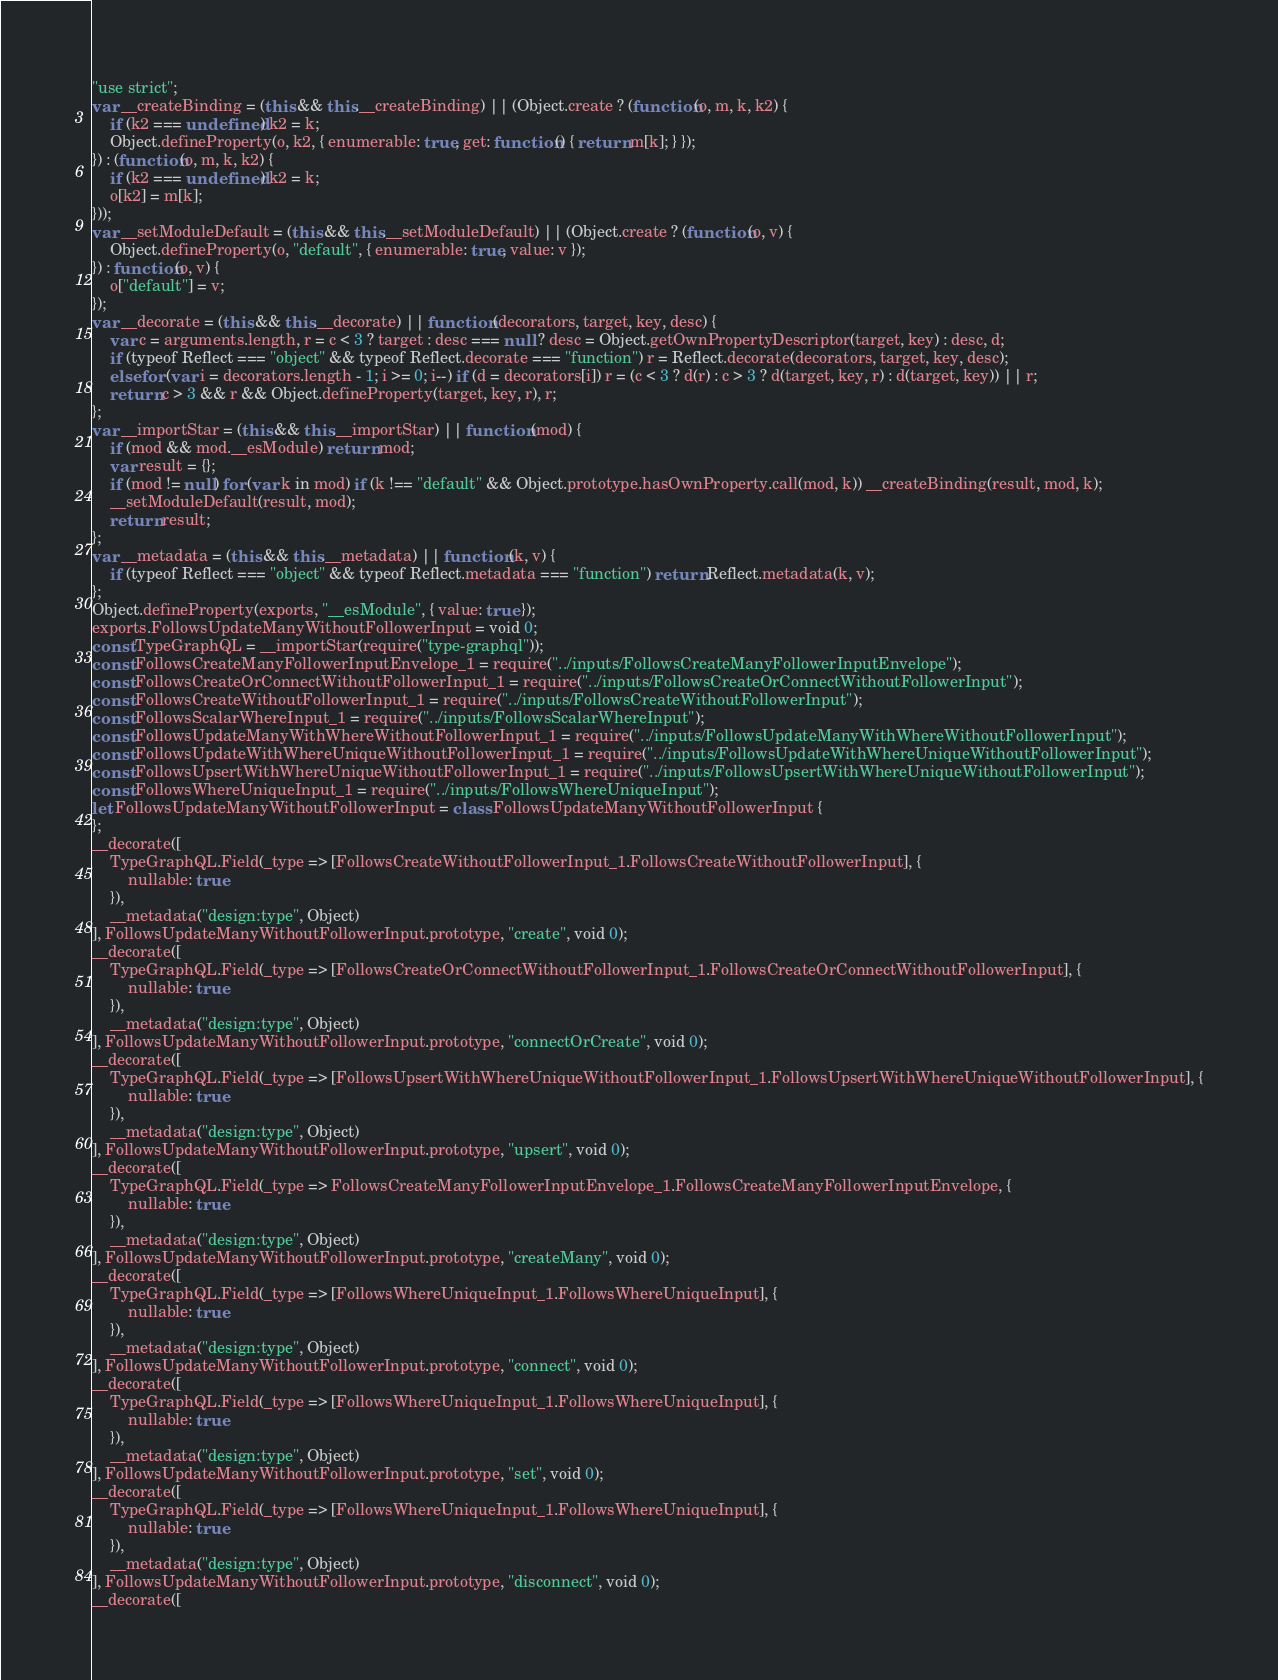Convert code to text. <code><loc_0><loc_0><loc_500><loc_500><_JavaScript_>"use strict";
var __createBinding = (this && this.__createBinding) || (Object.create ? (function(o, m, k, k2) {
    if (k2 === undefined) k2 = k;
    Object.defineProperty(o, k2, { enumerable: true, get: function() { return m[k]; } });
}) : (function(o, m, k, k2) {
    if (k2 === undefined) k2 = k;
    o[k2] = m[k];
}));
var __setModuleDefault = (this && this.__setModuleDefault) || (Object.create ? (function(o, v) {
    Object.defineProperty(o, "default", { enumerable: true, value: v });
}) : function(o, v) {
    o["default"] = v;
});
var __decorate = (this && this.__decorate) || function (decorators, target, key, desc) {
    var c = arguments.length, r = c < 3 ? target : desc === null ? desc = Object.getOwnPropertyDescriptor(target, key) : desc, d;
    if (typeof Reflect === "object" && typeof Reflect.decorate === "function") r = Reflect.decorate(decorators, target, key, desc);
    else for (var i = decorators.length - 1; i >= 0; i--) if (d = decorators[i]) r = (c < 3 ? d(r) : c > 3 ? d(target, key, r) : d(target, key)) || r;
    return c > 3 && r && Object.defineProperty(target, key, r), r;
};
var __importStar = (this && this.__importStar) || function (mod) {
    if (mod && mod.__esModule) return mod;
    var result = {};
    if (mod != null) for (var k in mod) if (k !== "default" && Object.prototype.hasOwnProperty.call(mod, k)) __createBinding(result, mod, k);
    __setModuleDefault(result, mod);
    return result;
};
var __metadata = (this && this.__metadata) || function (k, v) {
    if (typeof Reflect === "object" && typeof Reflect.metadata === "function") return Reflect.metadata(k, v);
};
Object.defineProperty(exports, "__esModule", { value: true });
exports.FollowsUpdateManyWithoutFollowerInput = void 0;
const TypeGraphQL = __importStar(require("type-graphql"));
const FollowsCreateManyFollowerInputEnvelope_1 = require("../inputs/FollowsCreateManyFollowerInputEnvelope");
const FollowsCreateOrConnectWithoutFollowerInput_1 = require("../inputs/FollowsCreateOrConnectWithoutFollowerInput");
const FollowsCreateWithoutFollowerInput_1 = require("../inputs/FollowsCreateWithoutFollowerInput");
const FollowsScalarWhereInput_1 = require("../inputs/FollowsScalarWhereInput");
const FollowsUpdateManyWithWhereWithoutFollowerInput_1 = require("../inputs/FollowsUpdateManyWithWhereWithoutFollowerInput");
const FollowsUpdateWithWhereUniqueWithoutFollowerInput_1 = require("../inputs/FollowsUpdateWithWhereUniqueWithoutFollowerInput");
const FollowsUpsertWithWhereUniqueWithoutFollowerInput_1 = require("../inputs/FollowsUpsertWithWhereUniqueWithoutFollowerInput");
const FollowsWhereUniqueInput_1 = require("../inputs/FollowsWhereUniqueInput");
let FollowsUpdateManyWithoutFollowerInput = class FollowsUpdateManyWithoutFollowerInput {
};
__decorate([
    TypeGraphQL.Field(_type => [FollowsCreateWithoutFollowerInput_1.FollowsCreateWithoutFollowerInput], {
        nullable: true
    }),
    __metadata("design:type", Object)
], FollowsUpdateManyWithoutFollowerInput.prototype, "create", void 0);
__decorate([
    TypeGraphQL.Field(_type => [FollowsCreateOrConnectWithoutFollowerInput_1.FollowsCreateOrConnectWithoutFollowerInput], {
        nullable: true
    }),
    __metadata("design:type", Object)
], FollowsUpdateManyWithoutFollowerInput.prototype, "connectOrCreate", void 0);
__decorate([
    TypeGraphQL.Field(_type => [FollowsUpsertWithWhereUniqueWithoutFollowerInput_1.FollowsUpsertWithWhereUniqueWithoutFollowerInput], {
        nullable: true
    }),
    __metadata("design:type", Object)
], FollowsUpdateManyWithoutFollowerInput.prototype, "upsert", void 0);
__decorate([
    TypeGraphQL.Field(_type => FollowsCreateManyFollowerInputEnvelope_1.FollowsCreateManyFollowerInputEnvelope, {
        nullable: true
    }),
    __metadata("design:type", Object)
], FollowsUpdateManyWithoutFollowerInput.prototype, "createMany", void 0);
__decorate([
    TypeGraphQL.Field(_type => [FollowsWhereUniqueInput_1.FollowsWhereUniqueInput], {
        nullable: true
    }),
    __metadata("design:type", Object)
], FollowsUpdateManyWithoutFollowerInput.prototype, "connect", void 0);
__decorate([
    TypeGraphQL.Field(_type => [FollowsWhereUniqueInput_1.FollowsWhereUniqueInput], {
        nullable: true
    }),
    __metadata("design:type", Object)
], FollowsUpdateManyWithoutFollowerInput.prototype, "set", void 0);
__decorate([
    TypeGraphQL.Field(_type => [FollowsWhereUniqueInput_1.FollowsWhereUniqueInput], {
        nullable: true
    }),
    __metadata("design:type", Object)
], FollowsUpdateManyWithoutFollowerInput.prototype, "disconnect", void 0);
__decorate([</code> 